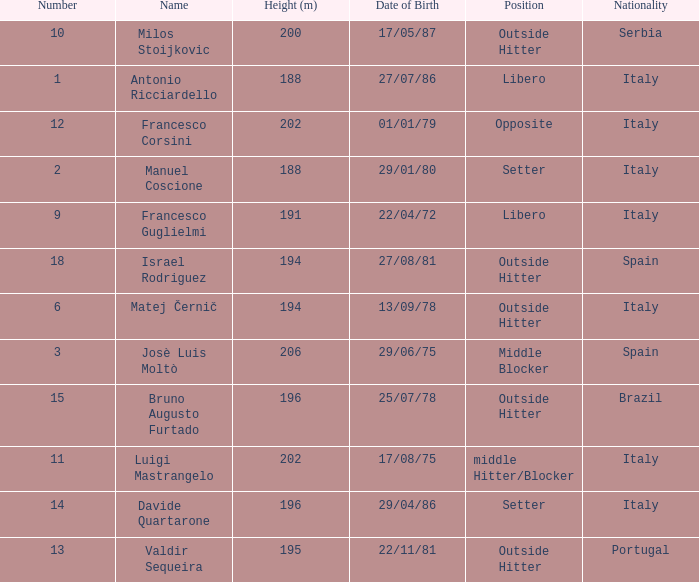Name the height for date of birth being 17/08/75 202.0. 